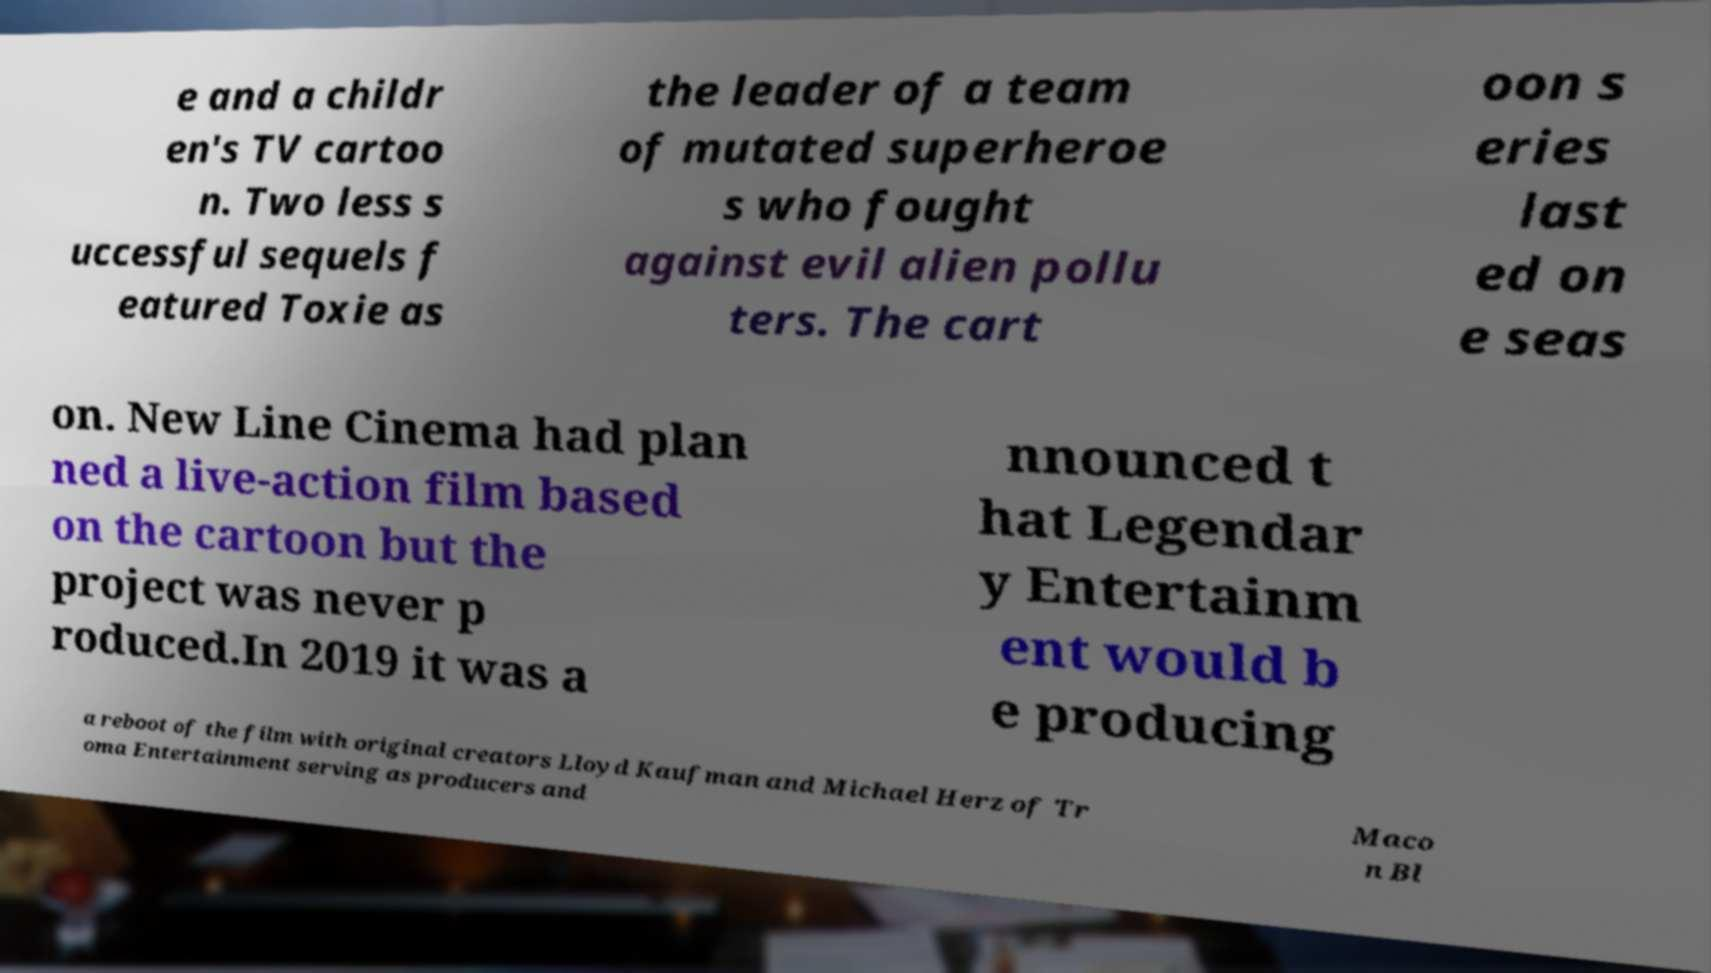Please read and relay the text visible in this image. What does it say? e and a childr en's TV cartoo n. Two less s uccessful sequels f eatured Toxie as the leader of a team of mutated superheroe s who fought against evil alien pollu ters. The cart oon s eries last ed on e seas on. New Line Cinema had plan ned a live-action film based on the cartoon but the project was never p roduced.In 2019 it was a nnounced t hat Legendar y Entertainm ent would b e producing a reboot of the film with original creators Lloyd Kaufman and Michael Herz of Tr oma Entertainment serving as producers and Maco n Bl 